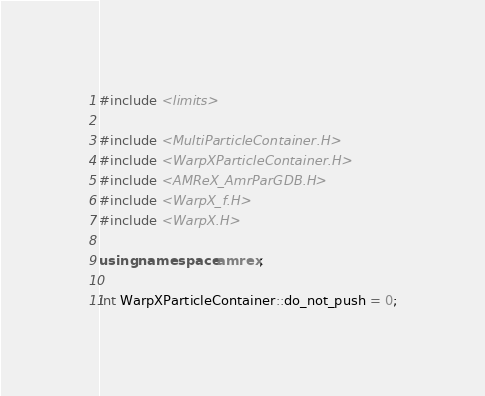<code> <loc_0><loc_0><loc_500><loc_500><_C++_>
#include <limits>

#include <MultiParticleContainer.H>
#include <WarpXParticleContainer.H>
#include <AMReX_AmrParGDB.H>
#include <WarpX_f.H>
#include <WarpX.H>

using namespace amrex;

int WarpXParticleContainer::do_not_push = 0;
</code> 